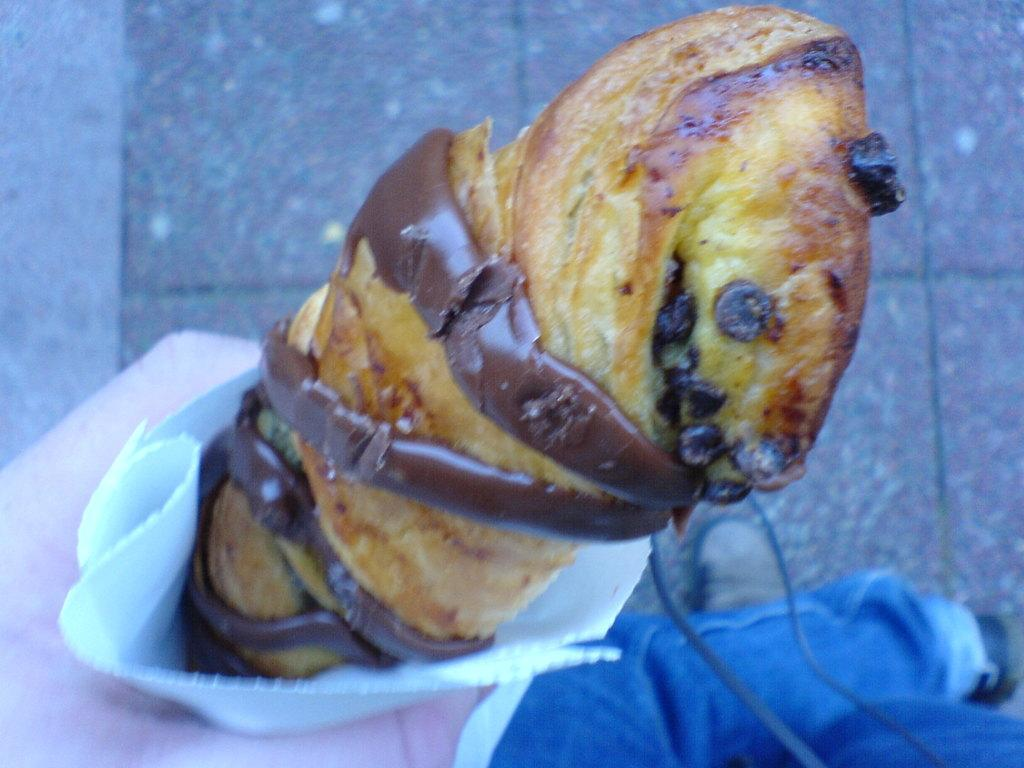What is the main subject of the image? There is a person in the image. What is the person holding in their hand? The person is holding a food item in their hand. What type of clothing is the person wearing? The person is wearing blue jeans. What can be seen in the background of the image? There is a floor visible in the background of the image. How many girls are present in the image? There is no mention of girls in the image; only a person is described. What type of cattle can be seen in the image? There is no cattle present in the image. Is there a coach visible in the image? There is no coach present in the image. 